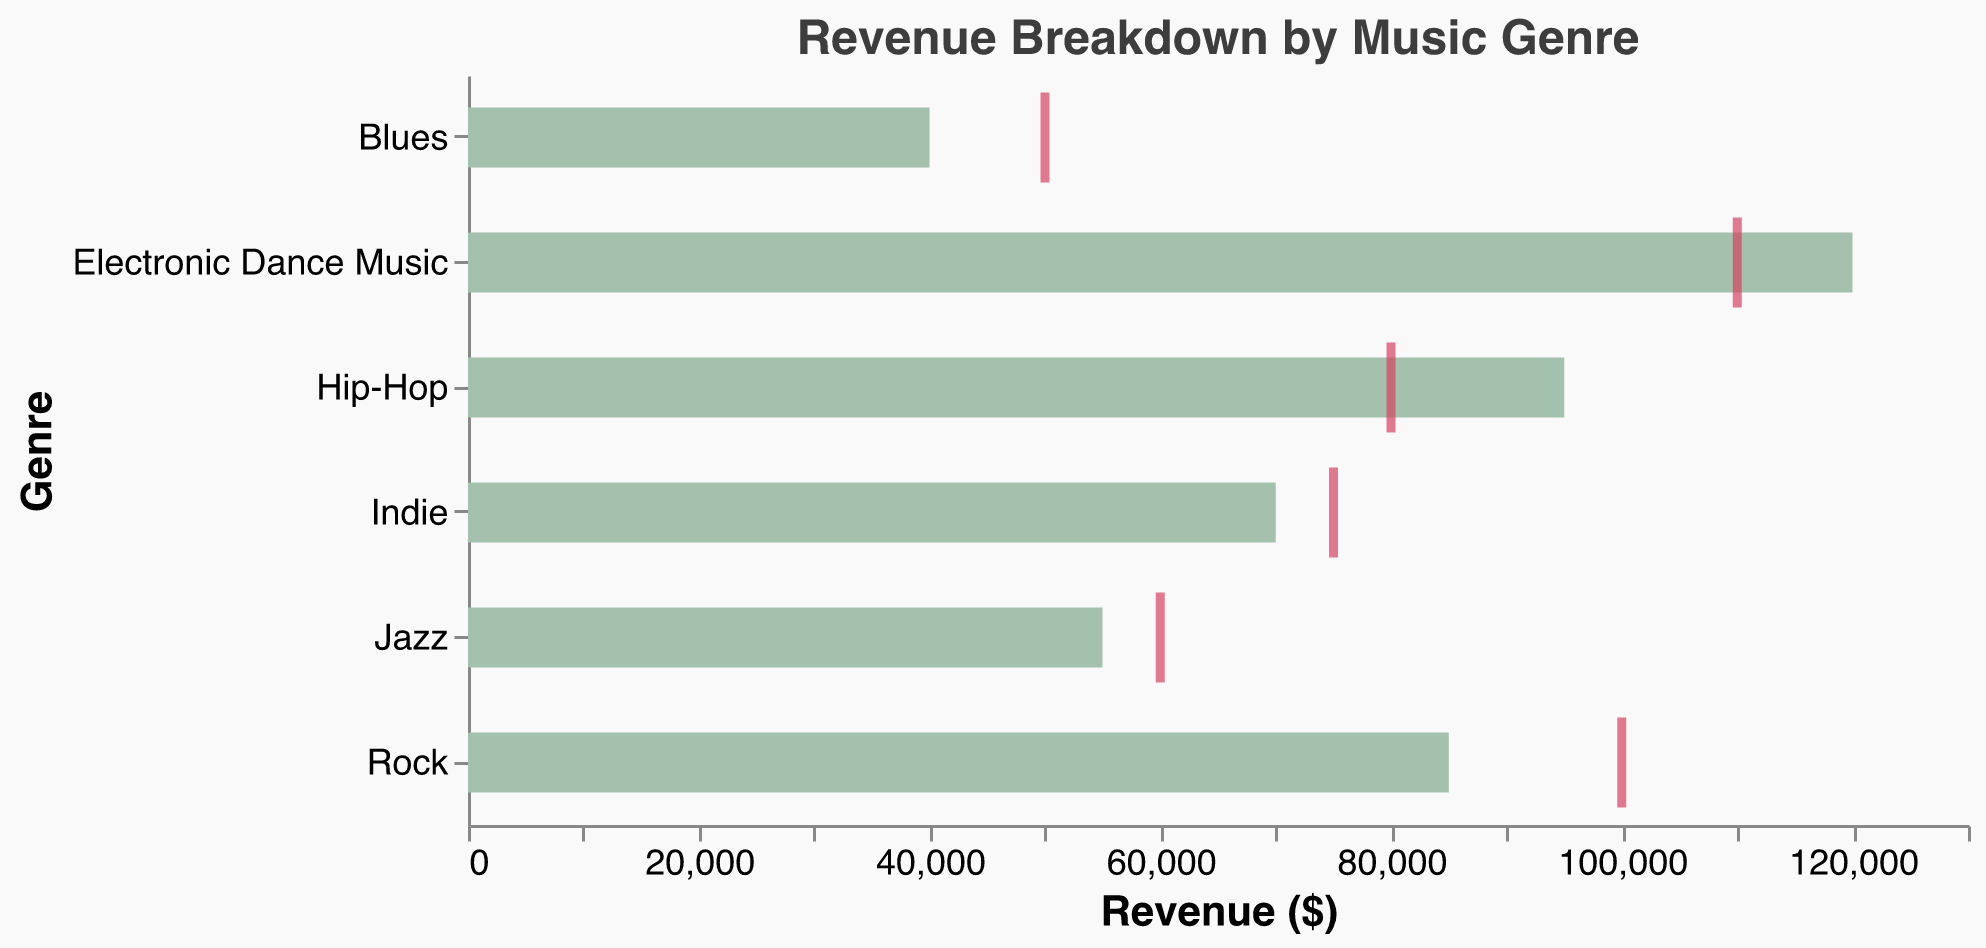What is the title of the chart? The title of the chart is displayed at the top middle of the chart in bold letters.
Answer: Revenue Breakdown by Music Genre Which genre has the highest actual revenue? The bar for "Electronic Dance Music" extends the farthest to the right, indicating the highest actual revenue.
Answer: Electronic Dance Music How does the actual revenue of Hip-Hop compare to its target revenue? The bar for Hip-Hop, representing actual revenue, extends beyond the tick mark which represents the target revenue.
Answer: Actual revenue is higher Which genre missed its target revenue by the largest margin? The genre with the longest gap between the end of the bar and its corresponding tick mark (left side of the tick) is Rock.
Answer: Rock What colors are used to represent actual and target revenues? Bars representing actual revenue are light green, while tick marks representing target revenue are red.
Answer: Light green and red How much more actual revenue did Indie generate compared to Blues? The actual revenues for Indie and Blues are $70,000 and $40,000 respectively. The difference is $70,000 - $40,000.
Answer: $30,000 Which genre has actual revenue closest to its target revenue? The genre with the shortest distance between the end of its bar and its tick mark is Jazz.
Answer: Jazz What is the total actual revenue for all genres combined? Adding up the actual revenues for all genres: $85,000 (Rock) + $120,000 (Electronic Dance Music) + $55,000 (Jazz) + $95,000 (Hip-Hop) + $70,000 (Indie) + $40,000 (Blues) = $465,000.
Answer: $465,000 Identify the genre where actual revenue is greater than target revenue and by how much. For Electronic Dance Music and Hip-Hop, the actual revenue is higher than the target revenue. EDM: $120,000 - $110,000 = $10,000. Hip-Hop: $95,000 - $80,000 = $15,000.
Answer: EDM by $10,000, Hip-Hop by $15,000 